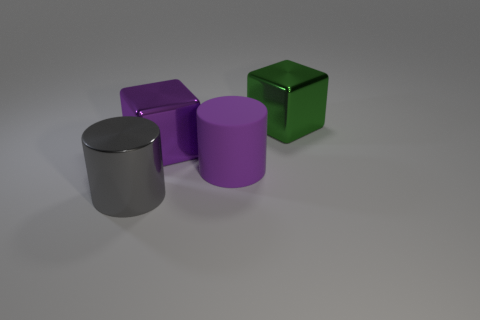Add 4 big gray shiny things. How many objects exist? 8 Add 4 purple things. How many purple things are left? 6 Add 4 big rubber balls. How many big rubber balls exist? 4 Subtract 1 purple cylinders. How many objects are left? 3 Subtract all purple rubber things. Subtract all large purple cylinders. How many objects are left? 2 